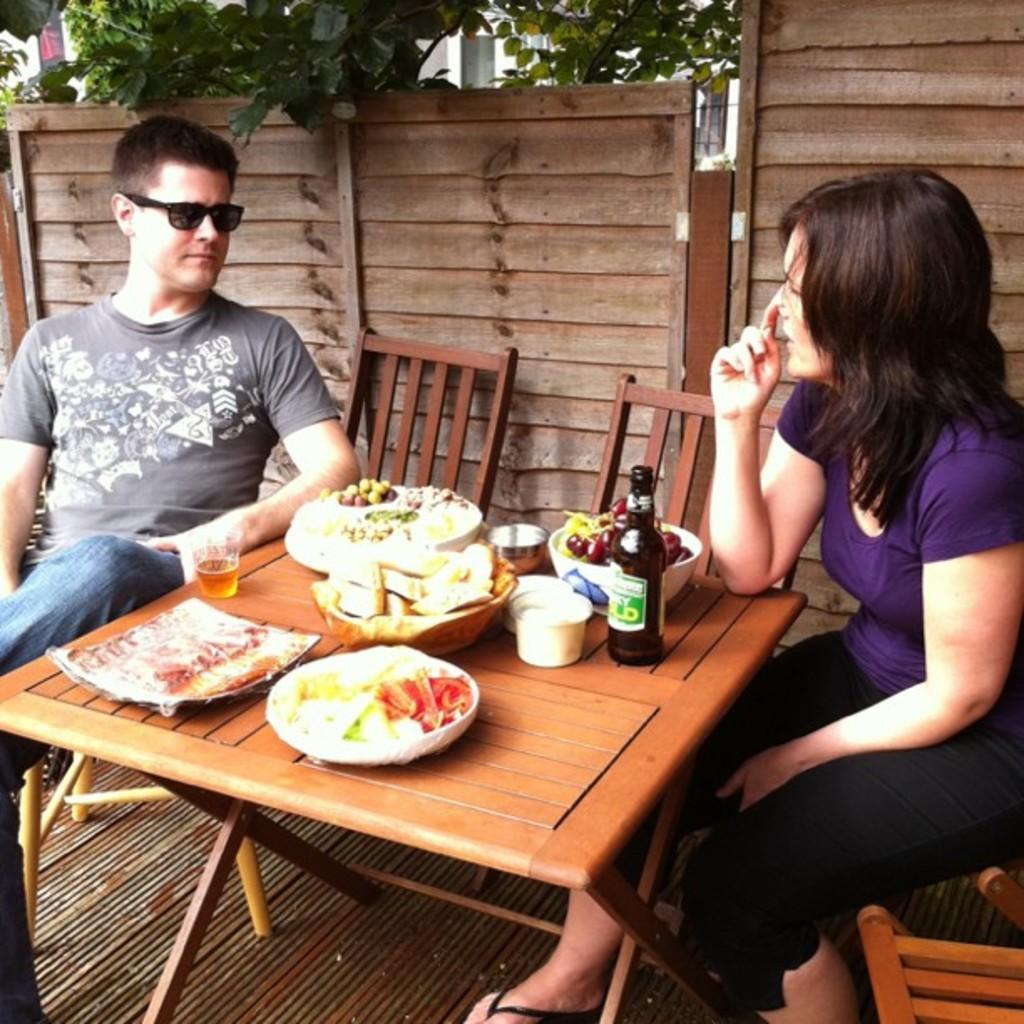In one or two sentences, can you explain what this image depicts? In this picture there is a man wearing the spectacles, sitting in the chair, in front of a woman. In between them there is a table on which some food items, plates, glasses and a bottle were placed. In the background, there is a wooden railing and some trees here. 